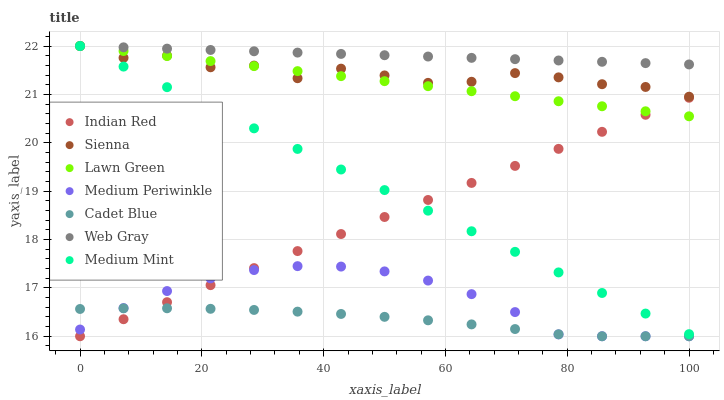Does Cadet Blue have the minimum area under the curve?
Answer yes or no. Yes. Does Web Gray have the maximum area under the curve?
Answer yes or no. Yes. Does Lawn Green have the minimum area under the curve?
Answer yes or no. No. Does Lawn Green have the maximum area under the curve?
Answer yes or no. No. Is Web Gray the smoothest?
Answer yes or no. Yes. Is Sienna the roughest?
Answer yes or no. Yes. Is Lawn Green the smoothest?
Answer yes or no. No. Is Lawn Green the roughest?
Answer yes or no. No. Does Cadet Blue have the lowest value?
Answer yes or no. Yes. Does Lawn Green have the lowest value?
Answer yes or no. No. Does Web Gray have the highest value?
Answer yes or no. Yes. Does Cadet Blue have the highest value?
Answer yes or no. No. Is Indian Red less than Sienna?
Answer yes or no. Yes. Is Web Gray greater than Cadet Blue?
Answer yes or no. Yes. Does Cadet Blue intersect Indian Red?
Answer yes or no. Yes. Is Cadet Blue less than Indian Red?
Answer yes or no. No. Is Cadet Blue greater than Indian Red?
Answer yes or no. No. Does Indian Red intersect Sienna?
Answer yes or no. No. 